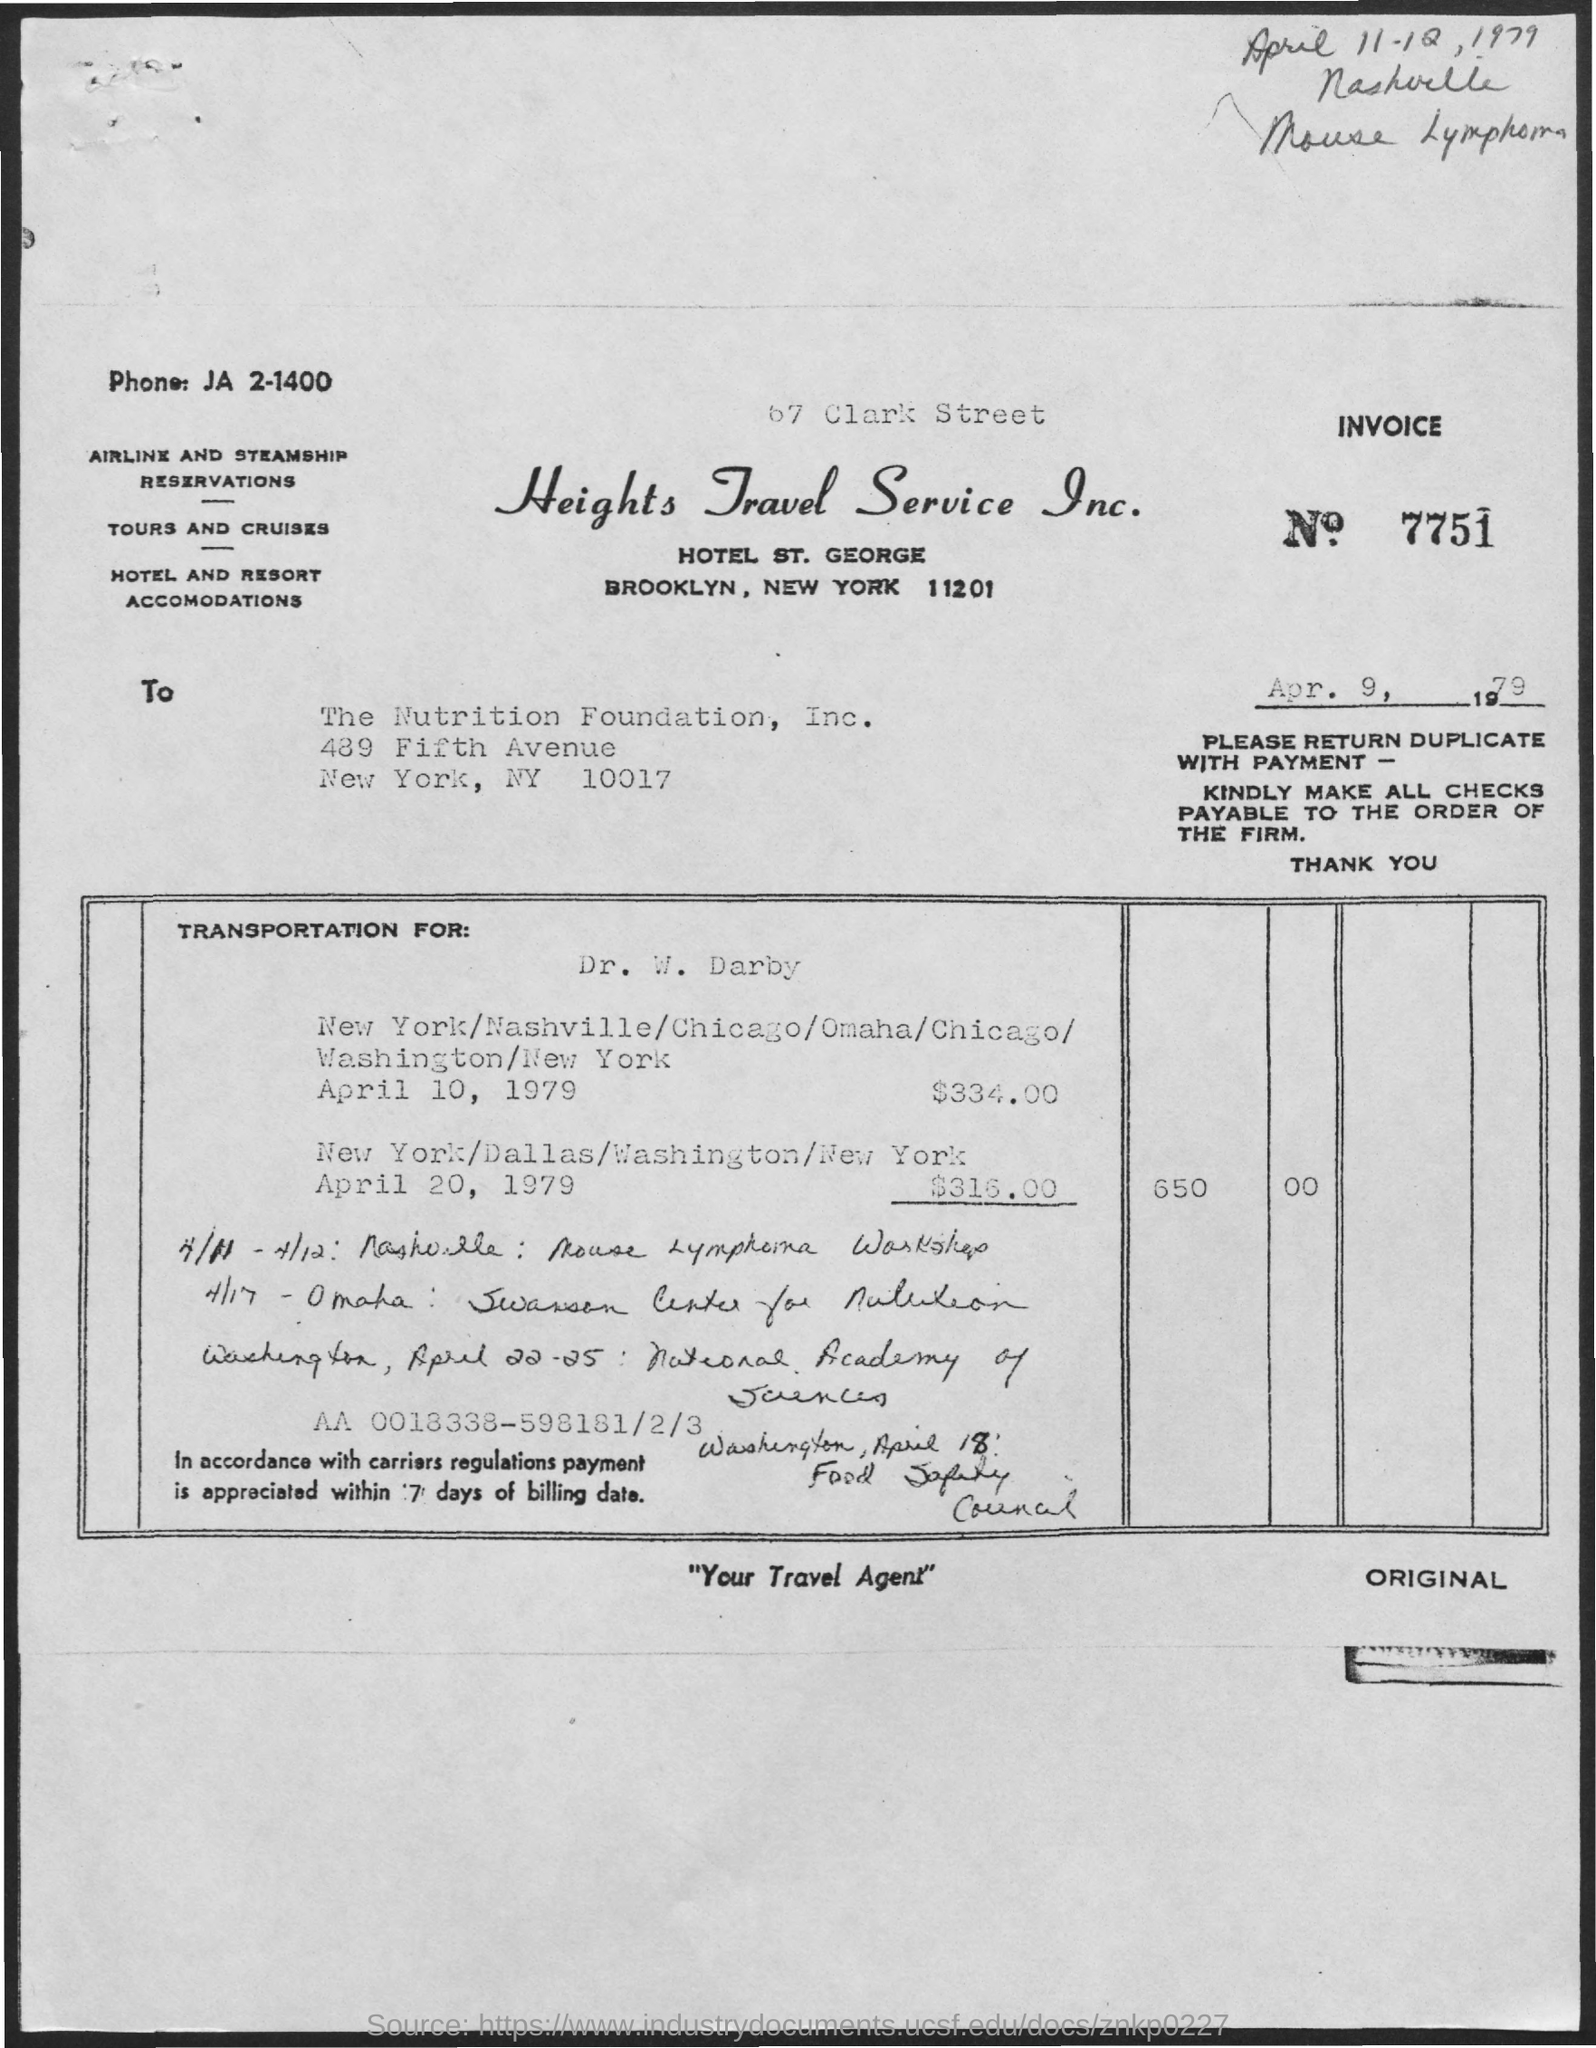What is the Invoice Number ?
Keep it short and to the point. 7751. 